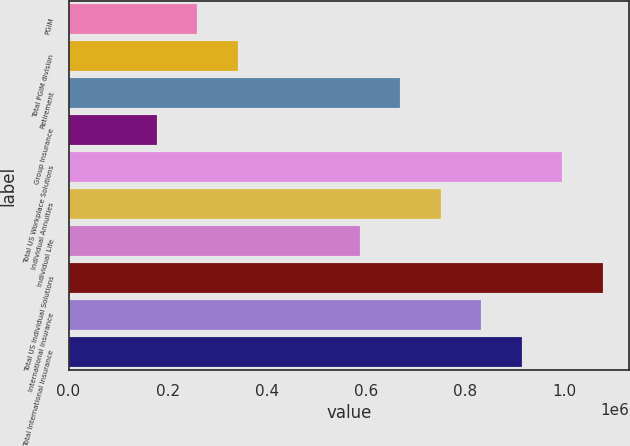<chart> <loc_0><loc_0><loc_500><loc_500><bar_chart><fcel>PGIM<fcel>Total PGIM division<fcel>Retirement<fcel>Group Insurance<fcel>Total US Workplace Solutions<fcel>Individual Annuities<fcel>Individual Life<fcel>Total US Individual Solutions<fcel>International Insurance<fcel>Total International Insurance<nl><fcel>259830<fcel>341588<fcel>668620<fcel>178072<fcel>995652<fcel>750378<fcel>586862<fcel>1.07741e+06<fcel>832136<fcel>913894<nl></chart> 